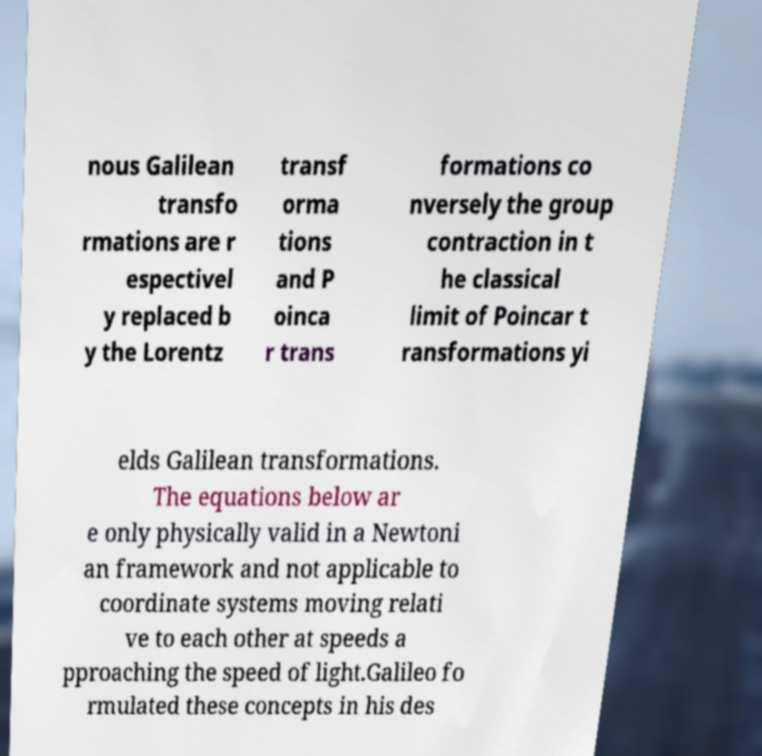Could you extract and type out the text from this image? nous Galilean transfo rmations are r espectivel y replaced b y the Lorentz transf orma tions and P oinca r trans formations co nversely the group contraction in t he classical limit of Poincar t ransformations yi elds Galilean transformations. The equations below ar e only physically valid in a Newtoni an framework and not applicable to coordinate systems moving relati ve to each other at speeds a pproaching the speed of light.Galileo fo rmulated these concepts in his des 